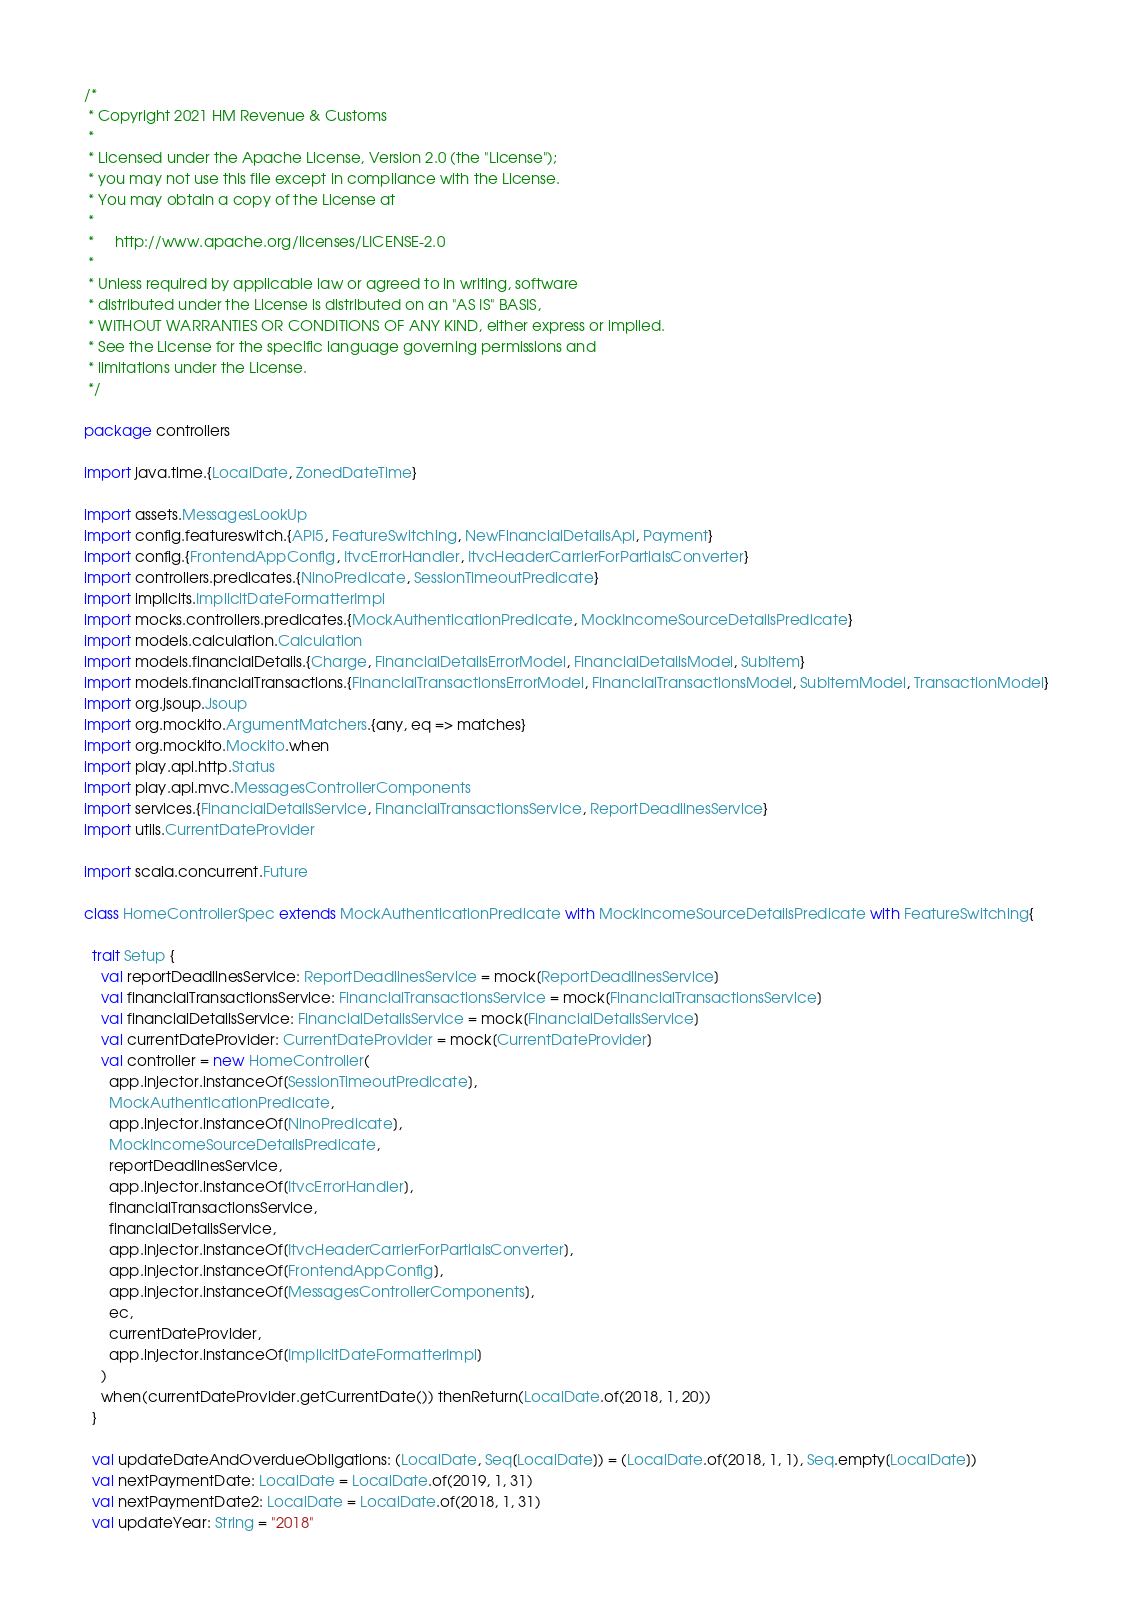Convert code to text. <code><loc_0><loc_0><loc_500><loc_500><_Scala_>/*
 * Copyright 2021 HM Revenue & Customs
 *
 * Licensed under the Apache License, Version 2.0 (the "License");
 * you may not use this file except in compliance with the License.
 * You may obtain a copy of the License at
 *
 *     http://www.apache.org/licenses/LICENSE-2.0
 *
 * Unless required by applicable law or agreed to in writing, software
 * distributed under the License is distributed on an "AS IS" BASIS,
 * WITHOUT WARRANTIES OR CONDITIONS OF ANY KIND, either express or implied.
 * See the License for the specific language governing permissions and
 * limitations under the License.
 */

package controllers

import java.time.{LocalDate, ZonedDateTime}

import assets.MessagesLookUp
import config.featureswitch.{API5, FeatureSwitching, NewFinancialDetailsApi, Payment}
import config.{FrontendAppConfig, ItvcErrorHandler, ItvcHeaderCarrierForPartialsConverter}
import controllers.predicates.{NinoPredicate, SessionTimeoutPredicate}
import implicits.ImplicitDateFormatterImpl
import mocks.controllers.predicates.{MockAuthenticationPredicate, MockIncomeSourceDetailsPredicate}
import models.calculation.Calculation
import models.financialDetails.{Charge, FinancialDetailsErrorModel, FinancialDetailsModel, SubItem}
import models.financialTransactions.{FinancialTransactionsErrorModel, FinancialTransactionsModel, SubItemModel, TransactionModel}
import org.jsoup.Jsoup
import org.mockito.ArgumentMatchers.{any, eq => matches}
import org.mockito.Mockito.when
import play.api.http.Status
import play.api.mvc.MessagesControllerComponents
import services.{FinancialDetailsService, FinancialTransactionsService, ReportDeadlinesService}
import utils.CurrentDateProvider

import scala.concurrent.Future

class HomeControllerSpec extends MockAuthenticationPredicate with MockIncomeSourceDetailsPredicate with FeatureSwitching{

  trait Setup {
    val reportDeadlinesService: ReportDeadlinesService = mock[ReportDeadlinesService]
    val financialTransactionsService: FinancialTransactionsService = mock[FinancialTransactionsService]
    val financialDetailsService: FinancialDetailsService = mock[FinancialDetailsService]
    val currentDateProvider: CurrentDateProvider = mock[CurrentDateProvider]
    val controller = new HomeController(
      app.injector.instanceOf[SessionTimeoutPredicate],
      MockAuthenticationPredicate,
      app.injector.instanceOf[NinoPredicate],
      MockIncomeSourceDetailsPredicate,
      reportDeadlinesService,
      app.injector.instanceOf[ItvcErrorHandler],
      financialTransactionsService,
      financialDetailsService,
      app.injector.instanceOf[ItvcHeaderCarrierForPartialsConverter],
      app.injector.instanceOf[FrontendAppConfig],
      app.injector.instanceOf[MessagesControllerComponents],
      ec,
      currentDateProvider,
      app.injector.instanceOf[ImplicitDateFormatterImpl]
    )
    when(currentDateProvider.getCurrentDate()) thenReturn(LocalDate.of(2018, 1, 20))
  }

  val updateDateAndOverdueObligations: (LocalDate, Seq[LocalDate]) = (LocalDate.of(2018, 1, 1), Seq.empty[LocalDate])
  val nextPaymentDate: LocalDate = LocalDate.of(2019, 1, 31)
  val nextPaymentDate2: LocalDate = LocalDate.of(2018, 1, 31)
  val updateYear: String = "2018"</code> 